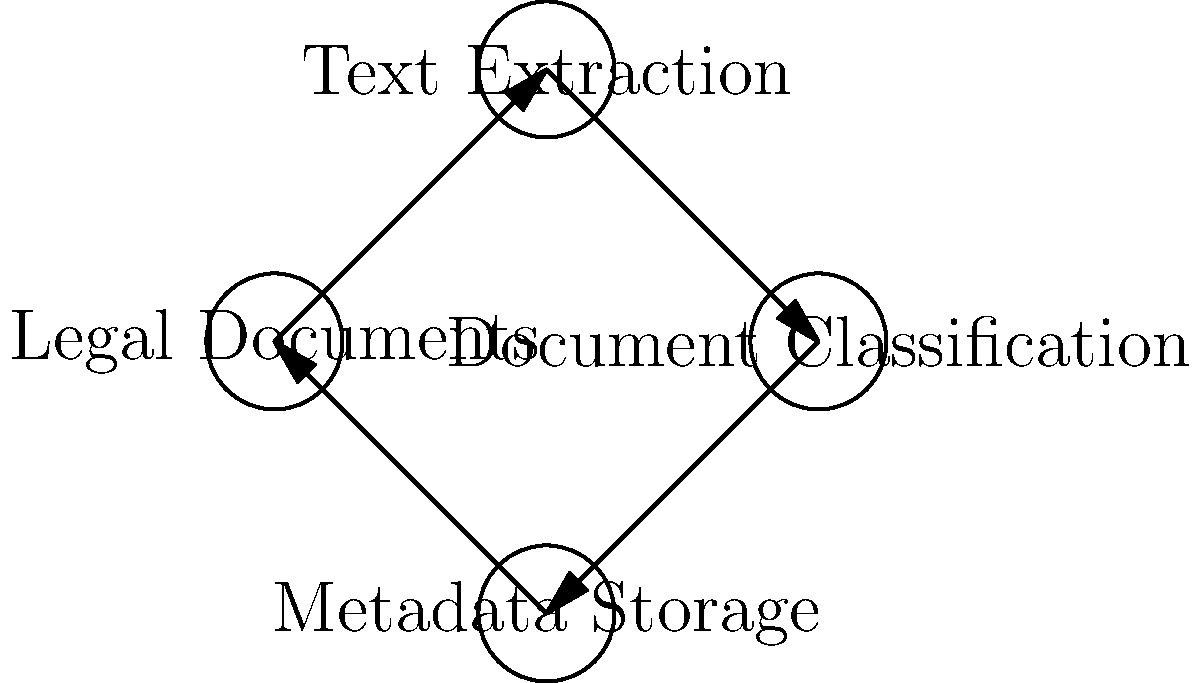Analyze the data flow diagram for legal document processing. Which component serves as both a data source and a destination in this circular flow? To determine which component serves as both a data source and a destination in this circular flow, let's analyze the diagram step-by-step:

1. The diagram shows four components: Legal Documents, Text Extraction, Document Classification, and Metadata Storage.

2. The arrows indicate the direction of data flow between these components.

3. Starting from "Legal Documents":
   - Data flows from Legal Documents to Text Extraction
   - Then from Text Extraction to Document Classification
   - Next from Document Classification to Metadata Storage
   - Finally, from Metadata Storage back to Legal Documents

4. This creates a circular flow of data through all four components.

5. To be both a source and destination, a component must have both incoming and outgoing arrows.

6. Examining each component:
   - Text Extraction: only incoming from Legal Documents, outgoing to Document Classification
   - Document Classification: only incoming from Text Extraction, outgoing to Metadata Storage
   - Metadata Storage: only incoming from Document Classification, outgoing to Legal Documents
   - Legal Documents: incoming from Metadata Storage, outgoing to Text Extraction

7. Among these, only "Legal Documents" has both an incoming arrow (from Metadata Storage) and an outgoing arrow (to Text Extraction).

Therefore, the "Legal Documents" component serves as both a data source and a destination in this circular flow.
Answer: Legal Documents 